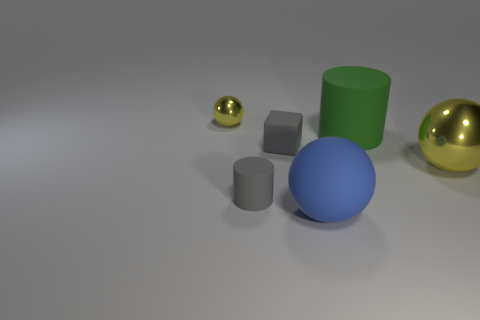Subtract all big rubber balls. How many balls are left? 2 Add 1 big red metallic spheres. How many objects exist? 7 Subtract all gray cubes. How many yellow balls are left? 2 Subtract all cylinders. How many objects are left? 4 Add 4 small rubber things. How many small rubber things exist? 6 Subtract all blue spheres. How many spheres are left? 2 Subtract 0 green cubes. How many objects are left? 6 Subtract 1 balls. How many balls are left? 2 Subtract all cyan blocks. Subtract all purple cylinders. How many blocks are left? 1 Subtract all large metal things. Subtract all green cylinders. How many objects are left? 4 